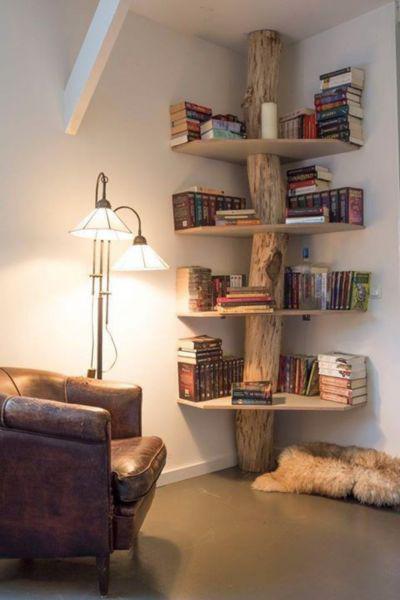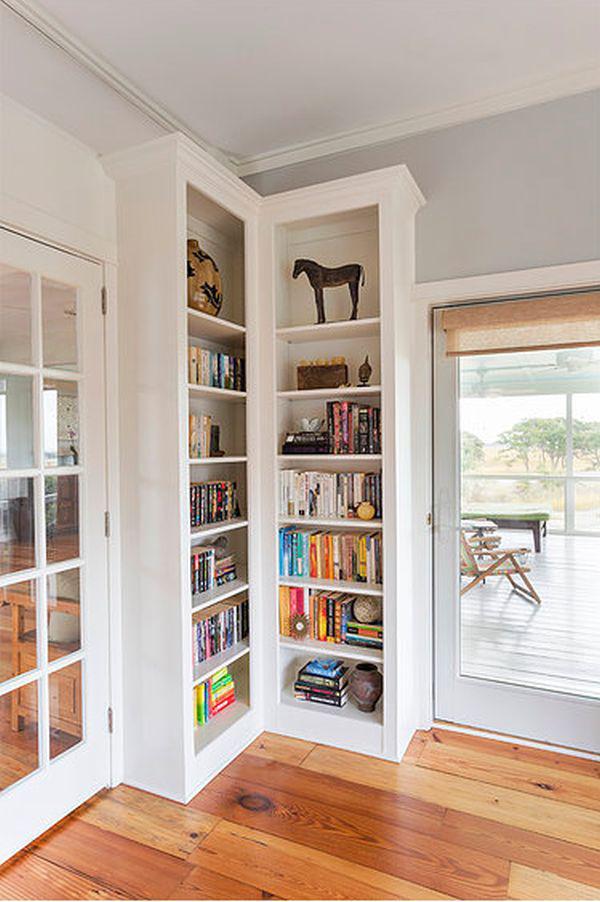The first image is the image on the left, the second image is the image on the right. Analyze the images presented: Is the assertion "An image shows a non-white corner bookshelf that includes at least some open ends" valid? Answer yes or no. Yes. The first image is the image on the left, the second image is the image on the right. For the images shown, is this caption "The bookshelf on the right covers an entire right-angle corner." true? Answer yes or no. Yes. 